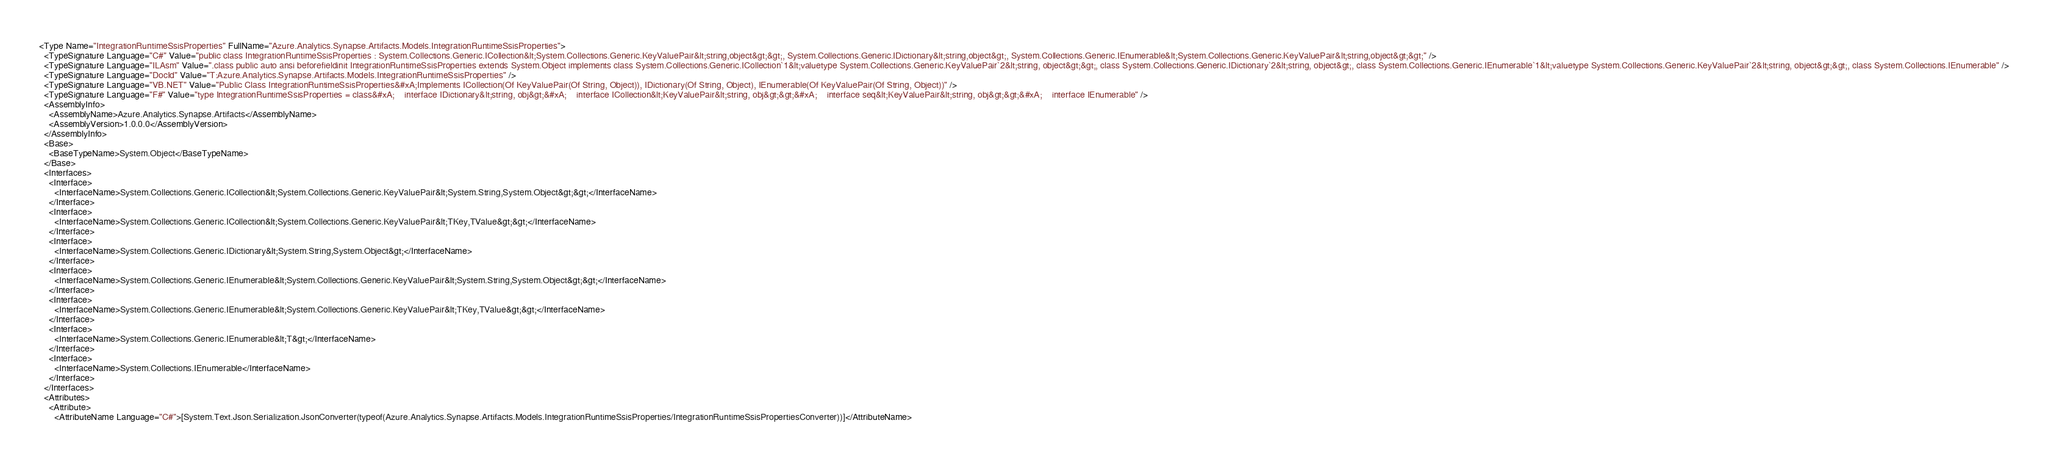Convert code to text. <code><loc_0><loc_0><loc_500><loc_500><_XML_><Type Name="IntegrationRuntimeSsisProperties" FullName="Azure.Analytics.Synapse.Artifacts.Models.IntegrationRuntimeSsisProperties">
  <TypeSignature Language="C#" Value="public class IntegrationRuntimeSsisProperties : System.Collections.Generic.ICollection&lt;System.Collections.Generic.KeyValuePair&lt;string,object&gt;&gt;, System.Collections.Generic.IDictionary&lt;string,object&gt;, System.Collections.Generic.IEnumerable&lt;System.Collections.Generic.KeyValuePair&lt;string,object&gt;&gt;" />
  <TypeSignature Language="ILAsm" Value=".class public auto ansi beforefieldinit IntegrationRuntimeSsisProperties extends System.Object implements class System.Collections.Generic.ICollection`1&lt;valuetype System.Collections.Generic.KeyValuePair`2&lt;string, object&gt;&gt;, class System.Collections.Generic.IDictionary`2&lt;string, object&gt;, class System.Collections.Generic.IEnumerable`1&lt;valuetype System.Collections.Generic.KeyValuePair`2&lt;string, object&gt;&gt;, class System.Collections.IEnumerable" />
  <TypeSignature Language="DocId" Value="T:Azure.Analytics.Synapse.Artifacts.Models.IntegrationRuntimeSsisProperties" />
  <TypeSignature Language="VB.NET" Value="Public Class IntegrationRuntimeSsisProperties&#xA;Implements ICollection(Of KeyValuePair(Of String, Object)), IDictionary(Of String, Object), IEnumerable(Of KeyValuePair(Of String, Object))" />
  <TypeSignature Language="F#" Value="type IntegrationRuntimeSsisProperties = class&#xA;    interface IDictionary&lt;string, obj&gt;&#xA;    interface ICollection&lt;KeyValuePair&lt;string, obj&gt;&gt;&#xA;    interface seq&lt;KeyValuePair&lt;string, obj&gt;&gt;&#xA;    interface IEnumerable" />
  <AssemblyInfo>
    <AssemblyName>Azure.Analytics.Synapse.Artifacts</AssemblyName>
    <AssemblyVersion>1.0.0.0</AssemblyVersion>
  </AssemblyInfo>
  <Base>
    <BaseTypeName>System.Object</BaseTypeName>
  </Base>
  <Interfaces>
    <Interface>
      <InterfaceName>System.Collections.Generic.ICollection&lt;System.Collections.Generic.KeyValuePair&lt;System.String,System.Object&gt;&gt;</InterfaceName>
    </Interface>
    <Interface>
      <InterfaceName>System.Collections.Generic.ICollection&lt;System.Collections.Generic.KeyValuePair&lt;TKey,TValue&gt;&gt;</InterfaceName>
    </Interface>
    <Interface>
      <InterfaceName>System.Collections.Generic.IDictionary&lt;System.String,System.Object&gt;</InterfaceName>
    </Interface>
    <Interface>
      <InterfaceName>System.Collections.Generic.IEnumerable&lt;System.Collections.Generic.KeyValuePair&lt;System.String,System.Object&gt;&gt;</InterfaceName>
    </Interface>
    <Interface>
      <InterfaceName>System.Collections.Generic.IEnumerable&lt;System.Collections.Generic.KeyValuePair&lt;TKey,TValue&gt;&gt;</InterfaceName>
    </Interface>
    <Interface>
      <InterfaceName>System.Collections.Generic.IEnumerable&lt;T&gt;</InterfaceName>
    </Interface>
    <Interface>
      <InterfaceName>System.Collections.IEnumerable</InterfaceName>
    </Interface>
  </Interfaces>
  <Attributes>
    <Attribute>
      <AttributeName Language="C#">[System.Text.Json.Serialization.JsonConverter(typeof(Azure.Analytics.Synapse.Artifacts.Models.IntegrationRuntimeSsisProperties/IntegrationRuntimeSsisPropertiesConverter))]</AttributeName></code> 